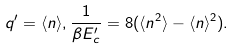Convert formula to latex. <formula><loc_0><loc_0><loc_500><loc_500>q ^ { \prime } = \langle n \rangle , \frac { 1 } { \beta E _ { c } ^ { \prime } } = 8 ( \langle n ^ { 2 } \rangle - \langle n \rangle ^ { 2 } ) .</formula> 